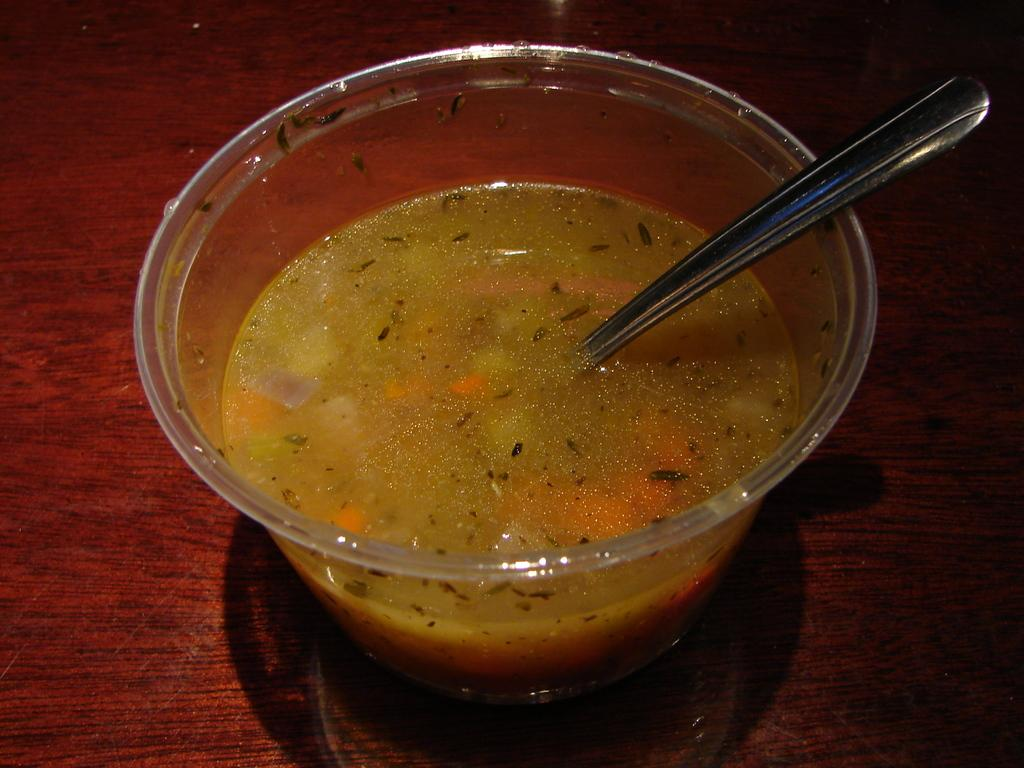What is in the bowl that is visible in the image? There is a bowl with soup in the image. What utensil is present in the bowl? There is a spoon in the bowl. On what surface is the bowl placed? The bowl is placed on a wooden surface. What type of paper is being requested in the image? There is no paper or request present in the image; it features a bowl of soup with a spoon on a wooden surface. 